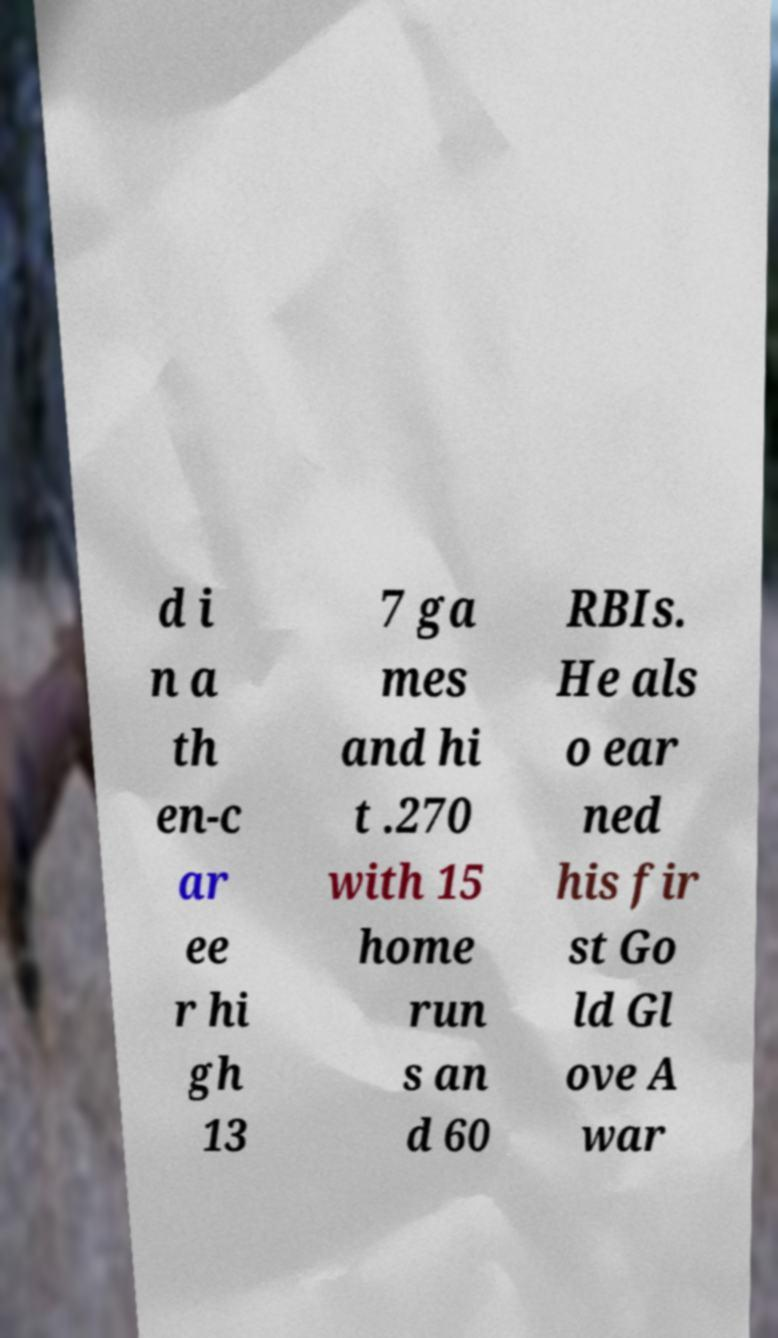What messages or text are displayed in this image? I need them in a readable, typed format. d i n a th en-c ar ee r hi gh 13 7 ga mes and hi t .270 with 15 home run s an d 60 RBIs. He als o ear ned his fir st Go ld Gl ove A war 